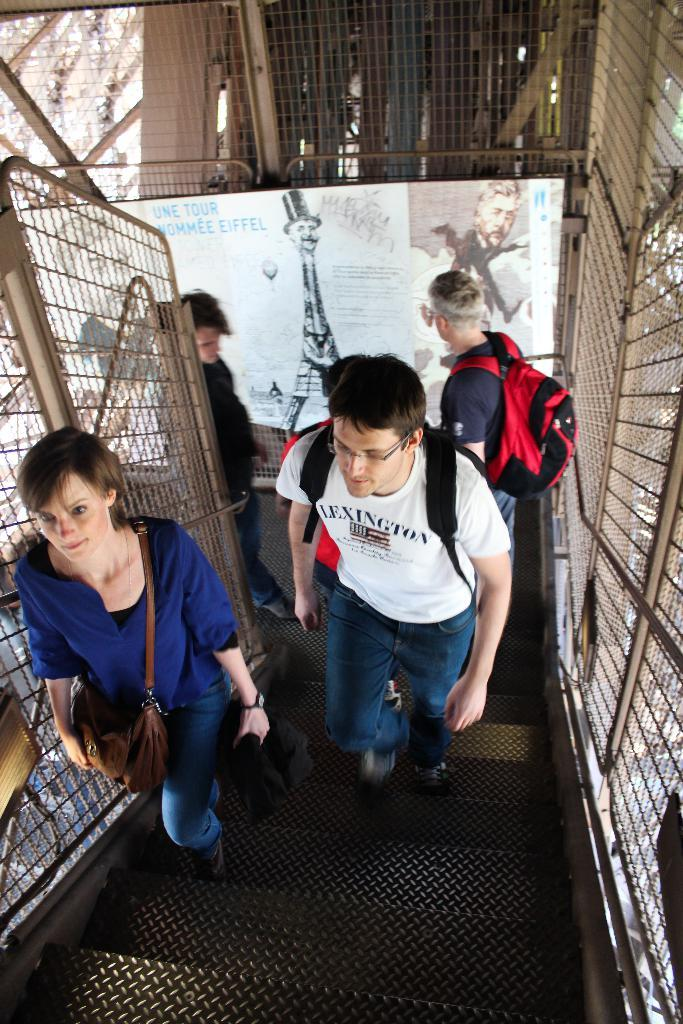How many people are in the image? There is a group of persons in the image. What are the persons doing in the image? The persons are walking through the stairs and carrying bags. What can be seen on the left and right sides of the image? There is fencing on the left and right sides of the image. Is there any fencing visible in the background? Yes, there is fencing in the background of the image. What type of scissors can be seen being used by the persons in the image? There are no scissors visible in the image; the persons are walking through the stairs and carrying bags. What topic are the persons discussing while walking through the stairs? There is no indication of a discussion taking place in the image; the persons are simply walking through the stairs and carrying bags. 